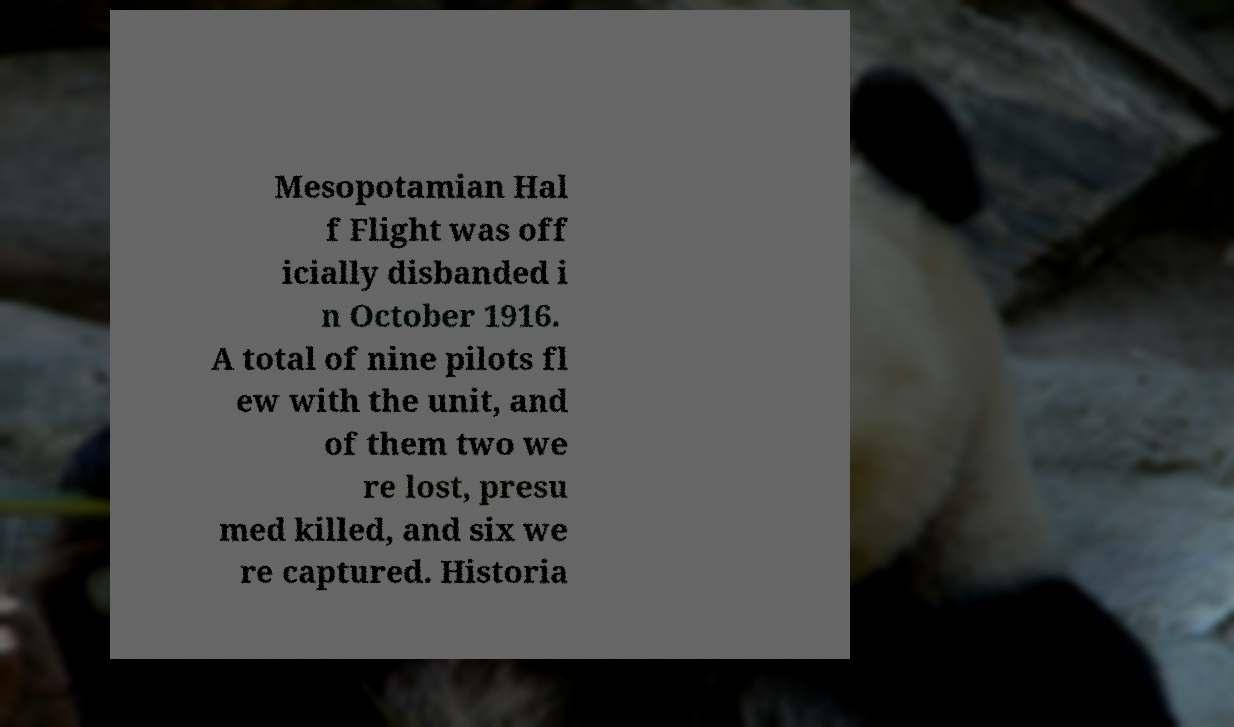Can you read and provide the text displayed in the image?This photo seems to have some interesting text. Can you extract and type it out for me? Mesopotamian Hal f Flight was off icially disbanded i n October 1916. A total of nine pilots fl ew with the unit, and of them two we re lost, presu med killed, and six we re captured. Historia 